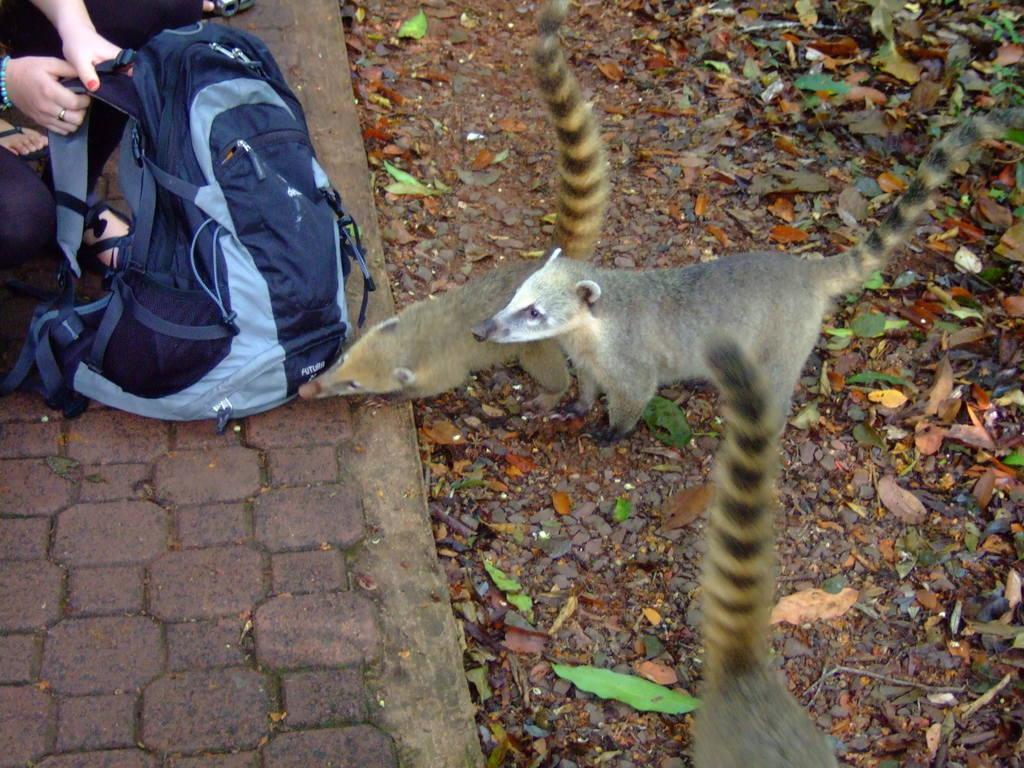How would you summarize this image in a sentence or two? In this image there are three squirrels one of the squirrel is licking the backpack and at the right side of the image there are different colors of leaves and at the left side of the image there are two women who are crouching on the sidewalk and holding a backpack 